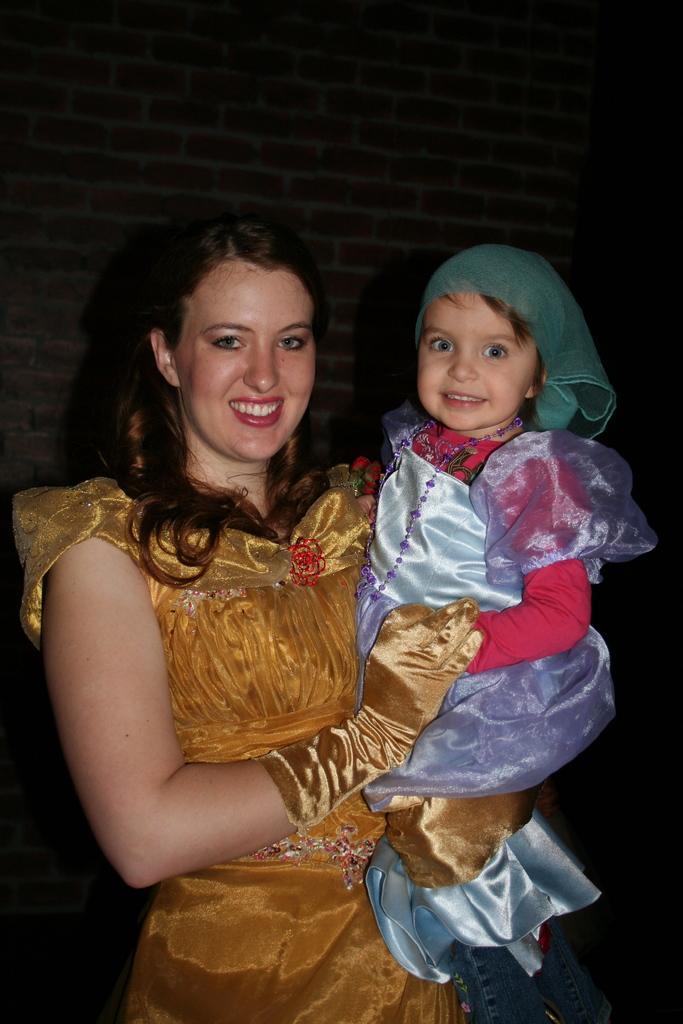How would you summarize this image in a sentence or two? Here in this picture we can see a woman carrying a child and standing over a place and both of them are smiling and we can see the woman is wearing gloves. 